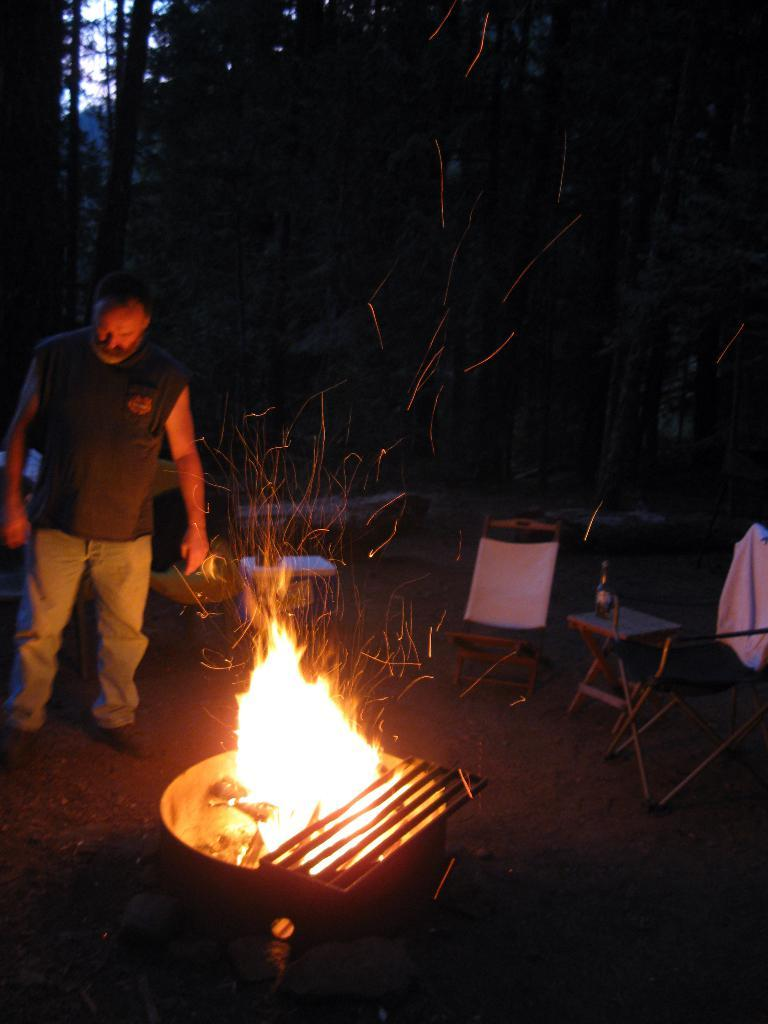What is the main subject of the image? There is a man in the image. What is the man holding in his left hand? The man is holding an object in his left hand. Can you describe the profession of the other person in the image? There is a fire captain in the image. What can be seen behind the subjects in the image? There is a backdrop in the image. What type of natural environment is visible in the image? There are trees visible in the image. What type of celery is being used as a prop in the image? There is no celery present in the image. Can you tell me a joke that the fire captain is telling in the image? There is no indication of a joke being told in the image. 